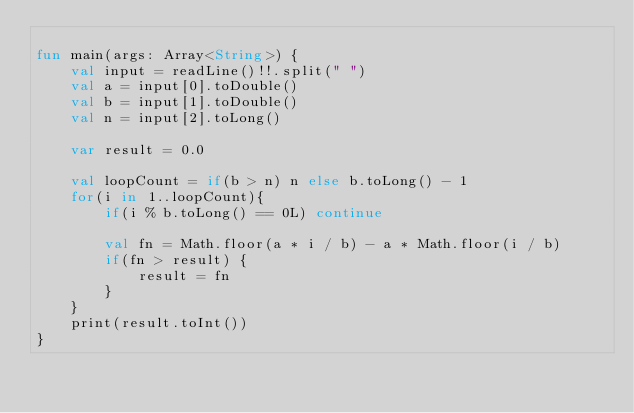<code> <loc_0><loc_0><loc_500><loc_500><_Kotlin_>
fun main(args: Array<String>) {
    val input = readLine()!!.split(" ")
    val a = input[0].toDouble()
    val b = input[1].toDouble()
    val n = input[2].toLong()

    var result = 0.0

    val loopCount = if(b > n) n else b.toLong() - 1
    for(i in 1..loopCount){
        if(i % b.toLong() == 0L) continue

        val fn = Math.floor(a * i / b) - a * Math.floor(i / b)
        if(fn > result) {
            result = fn
        }
    }
    print(result.toInt())
}</code> 